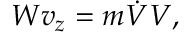Convert formula to latex. <formula><loc_0><loc_0><loc_500><loc_500>W v _ { z } = m { \dot { V } } V ,</formula> 